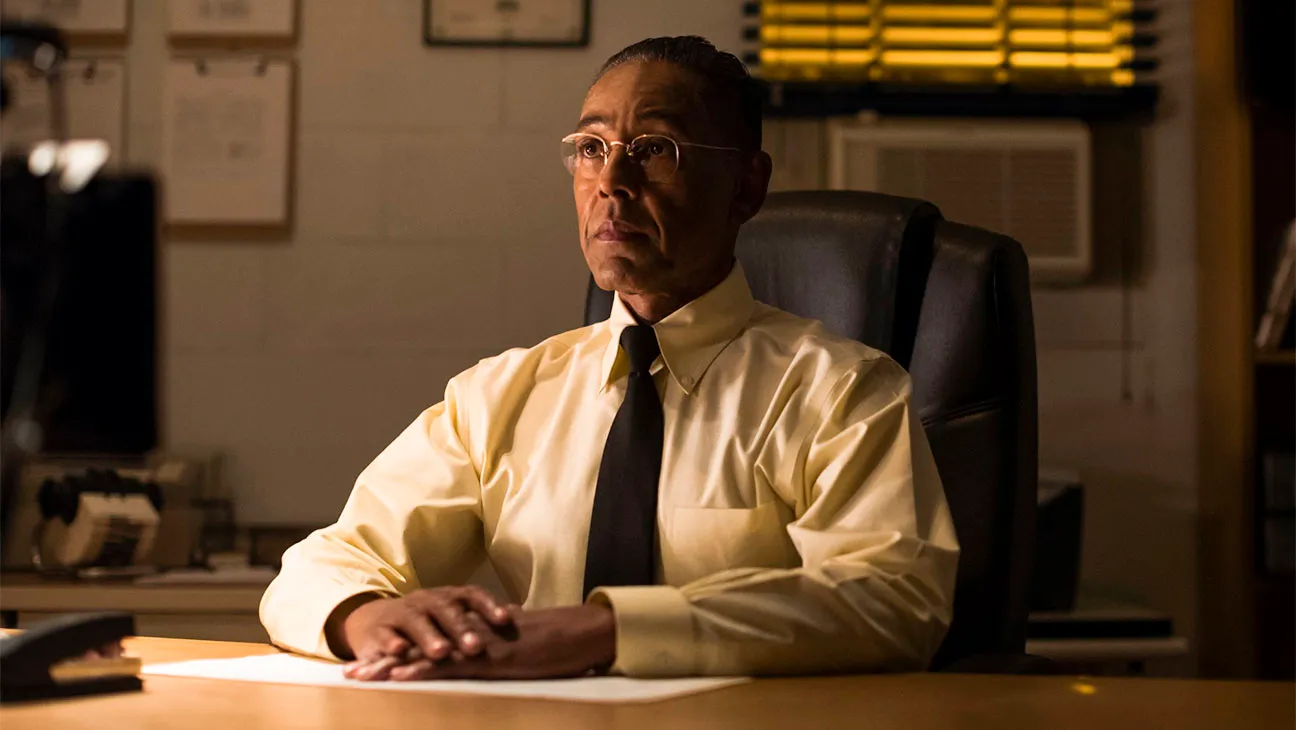What do you think the character in the image might be thinking about? The character appears to be deep in thought, possibly contemplating a critical decision or reflecting on recent events. His intense gaze and serious demeanor suggest that he might be considering a strategic move or dealing with a complex issue. The somber lighting and office environment add to the sense that he is engaged in something significant and possibly consequential. Could you invent a backstory for this character based on his appearance? Certainly! Imagine a man named sharegpt4v/samuel Morales, a high-ranking officer in a covert intelligence agency. sharegpt4v/samuel is known for his meticulous attention to detail and unwavering commitment to his work. Having climbed the ranks over a decade, he now oversees crucial operations from his dimly lit office. Today, he sits pondering the sensitive information in front of him, which could potentially expose a double agent within their ranks. The yellow blinds behind him filter the outside world from his secluded workspace, a metaphor for the intricate layers of secrecy in his life. His thoughtful expression reveals his struggle between loyalty and the harsh reality of making unforgiving decisions. 